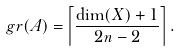<formula> <loc_0><loc_0><loc_500><loc_500>\ g r ( A ) & = \left \lceil \frac { \dim ( X ) + 1 } { 2 n - 2 } \right \rceil .</formula> 